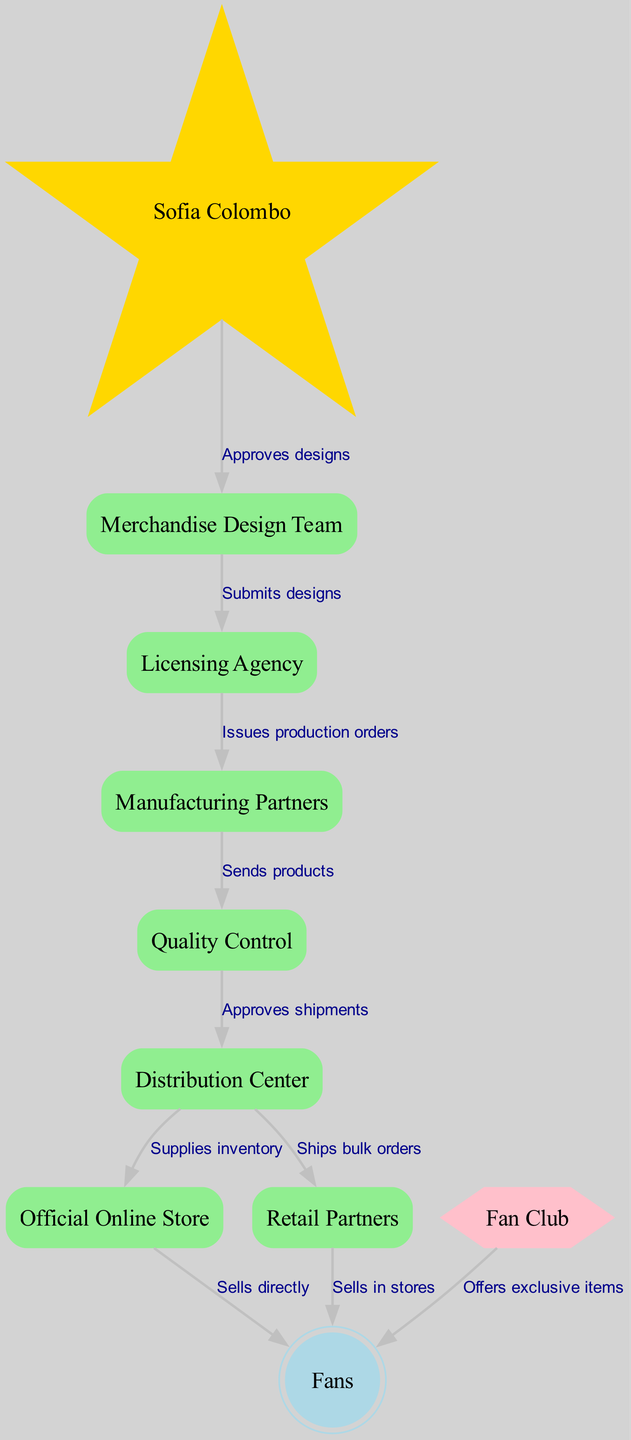What is the starting point of the merchandise production chain? The starting point is "Sofia Colombo," who initiates the process by approving designs created by the Merchandise Design Team.
Answer: Sofia Colombo How many nodes are in the diagram? By counting the nodes listed in the "nodes" section of the data, there are ten distinct nodes in the diagram.
Answer: 10 What relationship exists between the Merchandise Design Team and the Licensing Agency? The relationship is that the Merchandise Design Team submits designs to the Licensing Agency, which then facilitates the production process.
Answer: Submits designs Which node sells directly to fans? The node that sells directly to fans is the "Official Online Store," as indicated by a direct edge leading to "Fans."
Answer: Official Online Store What does the Quality Control node do after receiving products? The Quality Control node approves the shipments before they are sent to the Distribution Center, ensuring that products meet quality standards.
Answer: Approves shipments How many outgoing edges does the Distribution Center have? By examining the edges connected to the Distribution Center, it has two outgoing edges: one to the Official Online Store and another to Retail Partners.
Answer: 2 What type of items does the Fan Club offer to fans? The Fan Club offers exclusive items to fans, as shown by its direct relationship in the graph.
Answer: Exclusive items Which node issues production orders? The Licensing Agency is responsible for issuing production orders to the Manufacturing Partners as part of the merchandise production process.
Answer: Licensing Agency Who approves designs in the diagram? "Sofia Colombo" is the figure who approves designs, indicating her role in overseeing the creative process of merchandise.
Answer: Sofia Colombo 